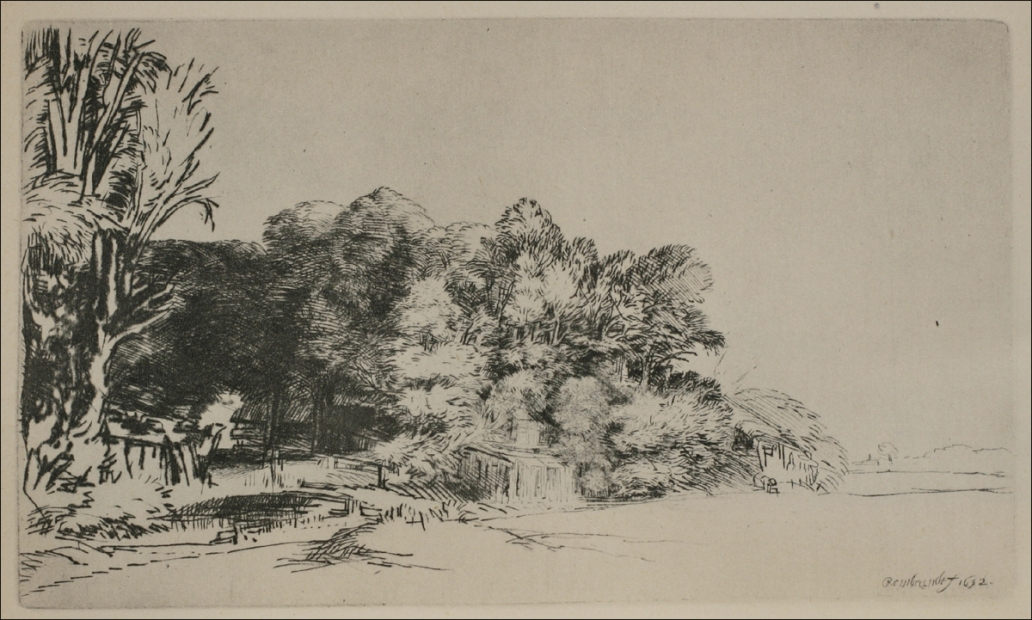What might be the significance of the path and fence in this landscape? The path and fence serve both aesthetic and thematic roles. Aesthetically, the path creates a leading line, drawing the viewer's eye into the depth of the image and encouraging exploration. Thematically, the path can represent a journey or the passage of time, while the fence might symbolize boundaries or the interface between the cultivated and wild aspects of nature. Together, they can suggest a narrative of travel or transition, inviting contemplation about where the path leads and the experiences one might encounter along the way. 